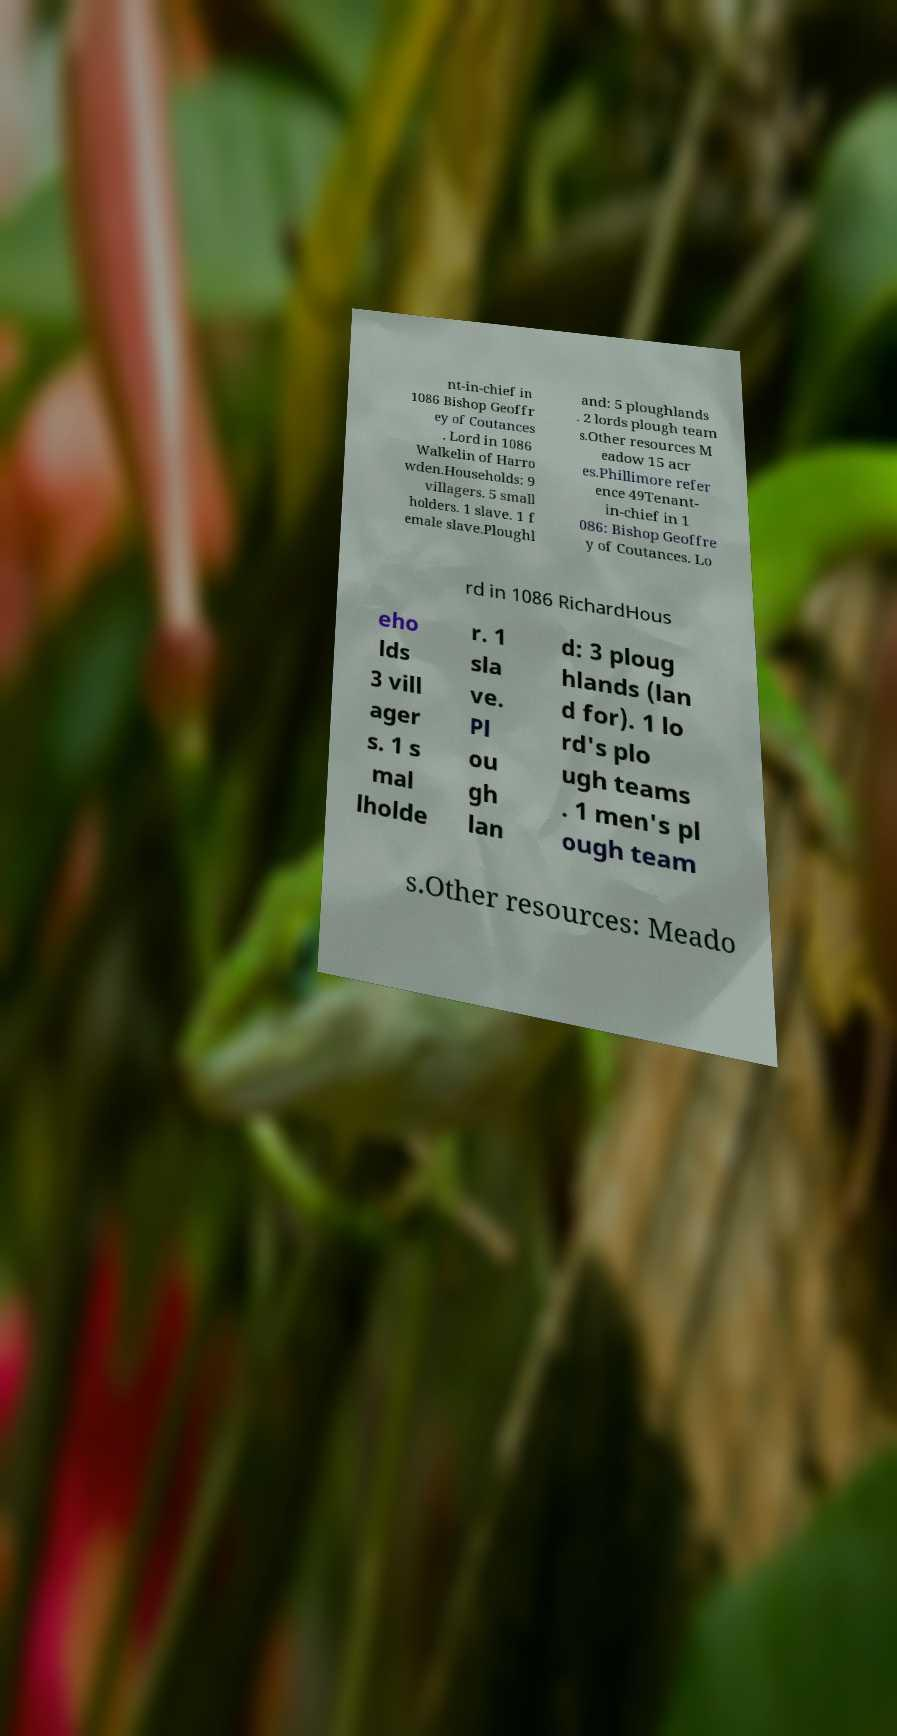Can you accurately transcribe the text from the provided image for me? nt-in-chief in 1086 Bishop Geoffr ey of Coutances . Lord in 1086 Walkelin of Harro wden.Households: 9 villagers. 5 small holders. 1 slave. 1 f emale slave.Ploughl and: 5 ploughlands . 2 lords plough team s.Other resources M eadow 15 acr es.Phillimore refer ence 49Tenant- in-chief in 1 086: Bishop Geoffre y of Coutances. Lo rd in 1086 RichardHous eho lds 3 vill ager s. 1 s mal lholde r. 1 sla ve. Pl ou gh lan d: 3 ploug hlands (lan d for). 1 lo rd's plo ugh teams . 1 men's pl ough team s.Other resources: Meado 